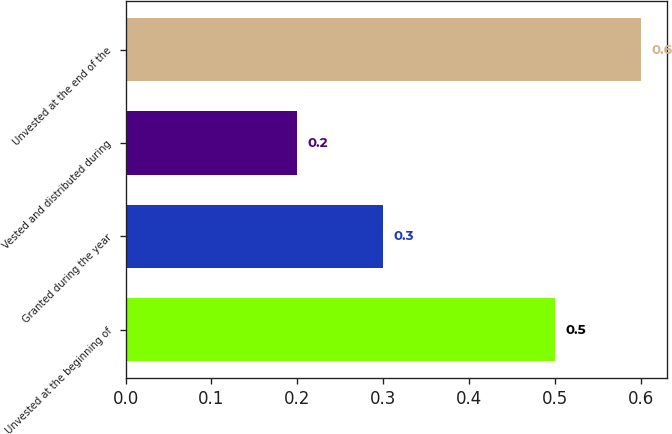<chart> <loc_0><loc_0><loc_500><loc_500><bar_chart><fcel>Unvested at the beginning of<fcel>Granted during the year<fcel>Vested and distributed during<fcel>Unvested at the end of the<nl><fcel>0.5<fcel>0.3<fcel>0.2<fcel>0.6<nl></chart> 